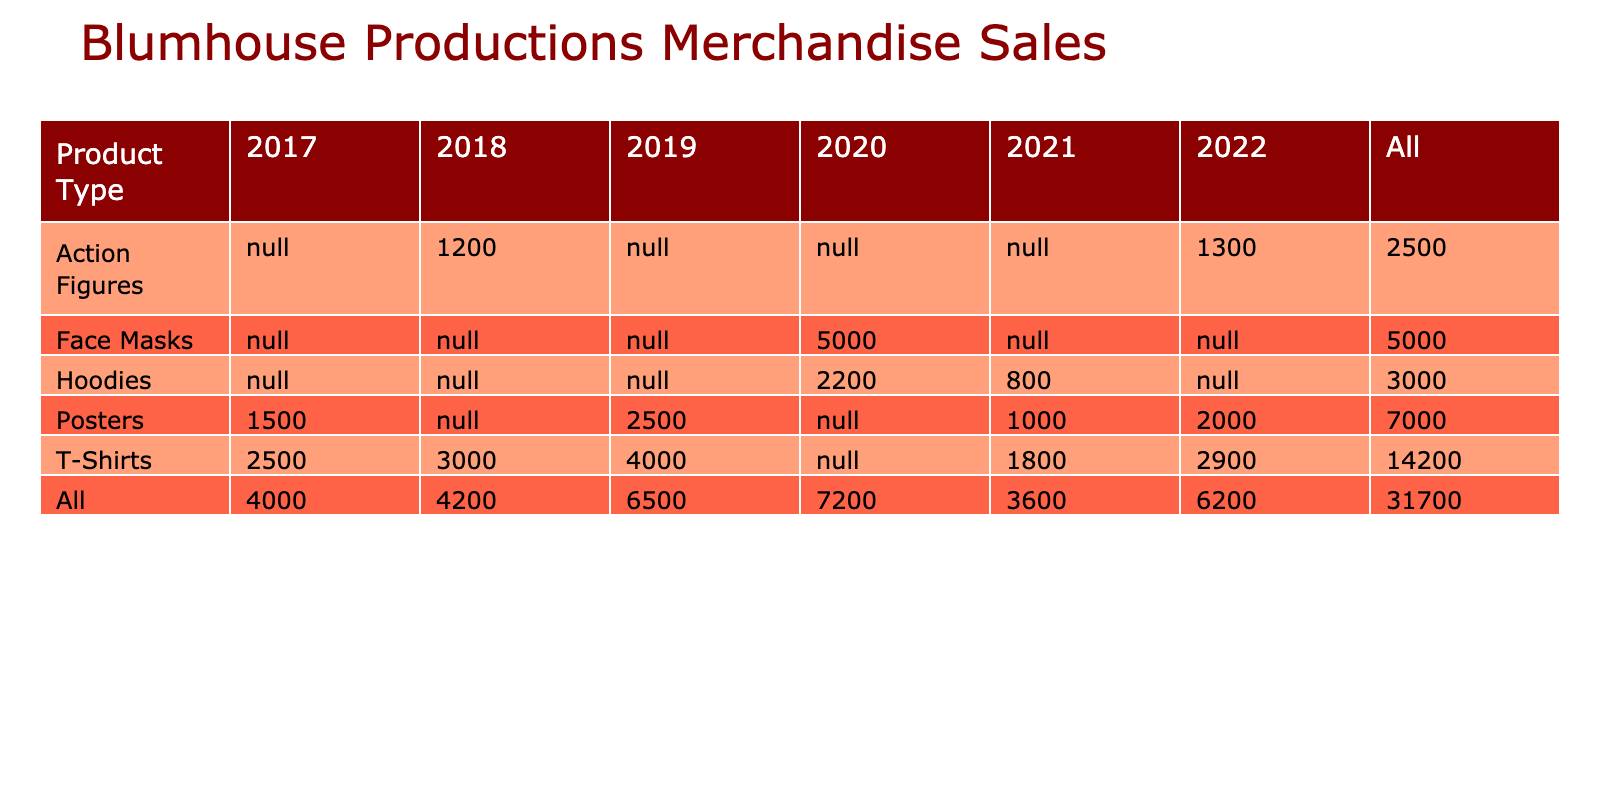What is the sales volume for T-Shirts in 2019? In the table, under the "T-Shirts" product type and "2019" year, the sales volume is listed as 4000 units.
Answer: 4000 What is the total revenue generated from Posters in 2021? To find the total revenue from Posters in 2021, we look at the row for Posters and the year 2021 where the revenue is $15,000.
Answer: 15000 Which product type had the highest sales volume in 2020? In the row for the year 2020, we look at the sales volume for different product types: Hoodies (2200) and Face Masks (5000). The Face Masks have the highest sales volume at 5000 units.
Answer: Face Masks What is the average sales volume of Action Figures across all years? The sales volumes for Action Figures are: 1200 (2018) and 1300 (2022). The average is calculated as (1200 + 1300) / 2 = 1250.
Answer: 1250 Did the sales volume of T-Shirts in 2022 exceed the sales volume of T-Shirts in 2021? In 2022, T-Shirts sold 2900 units and in 2021 they sold 1800 units. Since 2900 is greater than 1800, the answer is yes.
Answer: Yes What is the total revenue from merchandise sales for the film "Get Out"? For "Get Out," we have sales volumes of 2500 units for T-Shirts ($37,500) and 1500 units for Posters ($22,500). Summing these revenues gives $37,500 + $22,500 = $60,000.
Answer: 60000 What was the difference in sales volume for T-Shirts between 2018 and 2022? T-Shirts sold 3000 units in 2018 and 2900 units in 2022. The difference is 3000 - 2900 = 100 units.
Answer: 100 In which year did the film "Us" generate the highest revenue? For the film "Us," the revenue from T-Shirts in 2019 is $60,000 and Posters is $37,500, totaling $97,500. This is the highest revenue for Us compared to other years.
Answer: 2019 How many total units were sold for all product types in 2021? The units sold in 2021 are: T-Shirts (1800), Posters (1000), and Hoodies (800). The total is 1800 + 1000 + 800 = 3600 units.
Answer: 3600 